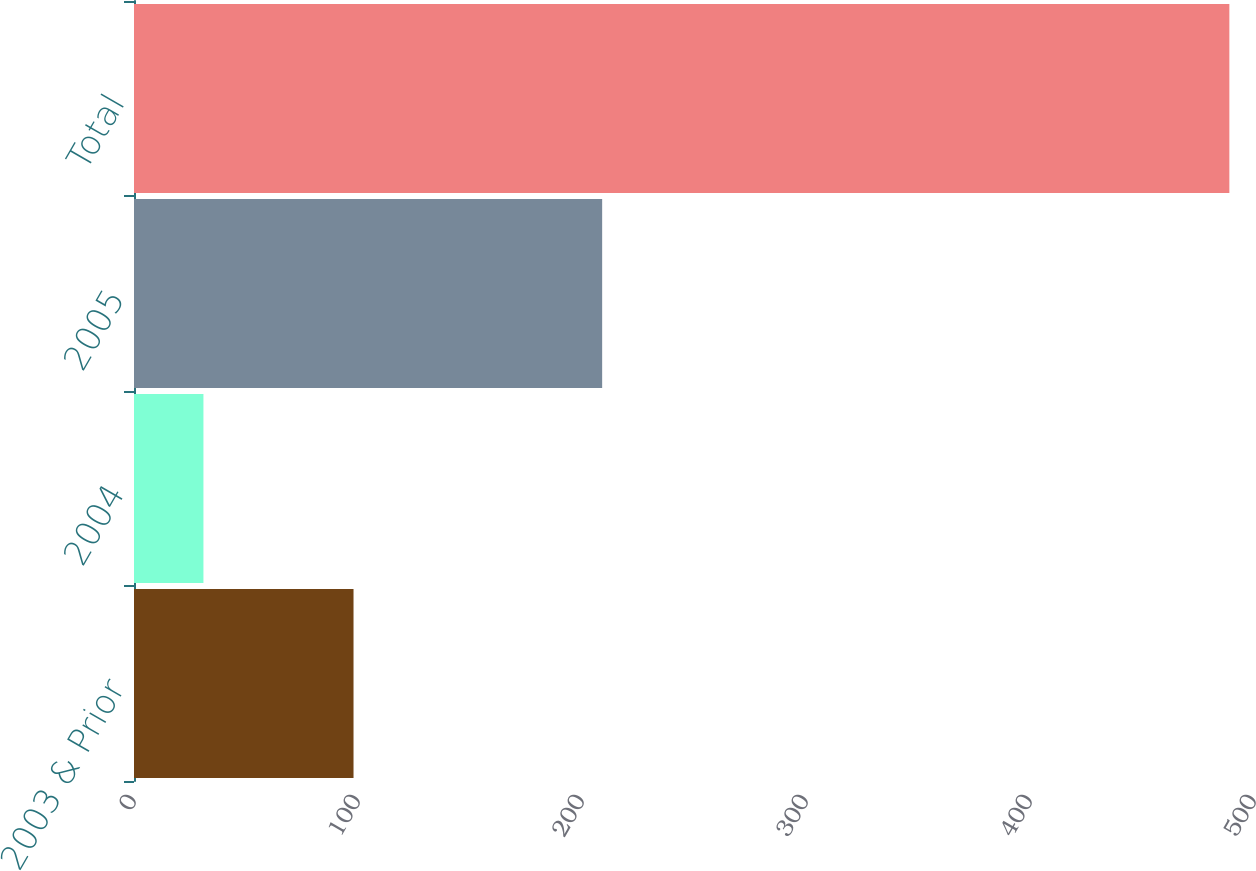Convert chart to OTSL. <chart><loc_0><loc_0><loc_500><loc_500><bar_chart><fcel>2003 & Prior<fcel>2004<fcel>2005<fcel>Total<nl><fcel>98<fcel>31<fcel>209<fcel>489<nl></chart> 